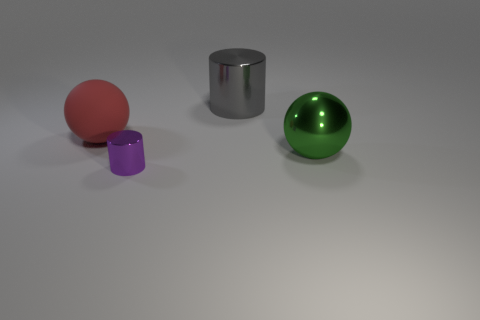Is the green thing made of the same material as the small cylinder?
Your response must be concise. Yes. Are there more large red objects than yellow metallic cylinders?
Give a very brief answer. Yes. There is a large metallic object left of the big sphere that is in front of the red sphere; what shape is it?
Ensure brevity in your answer.  Cylinder. There is a sphere behind the big object that is on the right side of the gray shiny object; is there a big thing in front of it?
Offer a very short reply. Yes. There is a metal thing that is the same size as the gray metallic cylinder; what is its color?
Your answer should be compact. Green. What shape is the object that is behind the tiny shiny thing and left of the gray shiny object?
Make the answer very short. Sphere. There is a metallic cylinder behind the big thing left of the purple metal thing; what size is it?
Ensure brevity in your answer.  Large. What number of other things are the same size as the matte sphere?
Your answer should be very brief. 2. How big is the metallic thing that is in front of the large rubber thing and on the left side of the large green object?
Give a very brief answer. Small. How many green objects have the same shape as the large red matte object?
Keep it short and to the point. 1. 